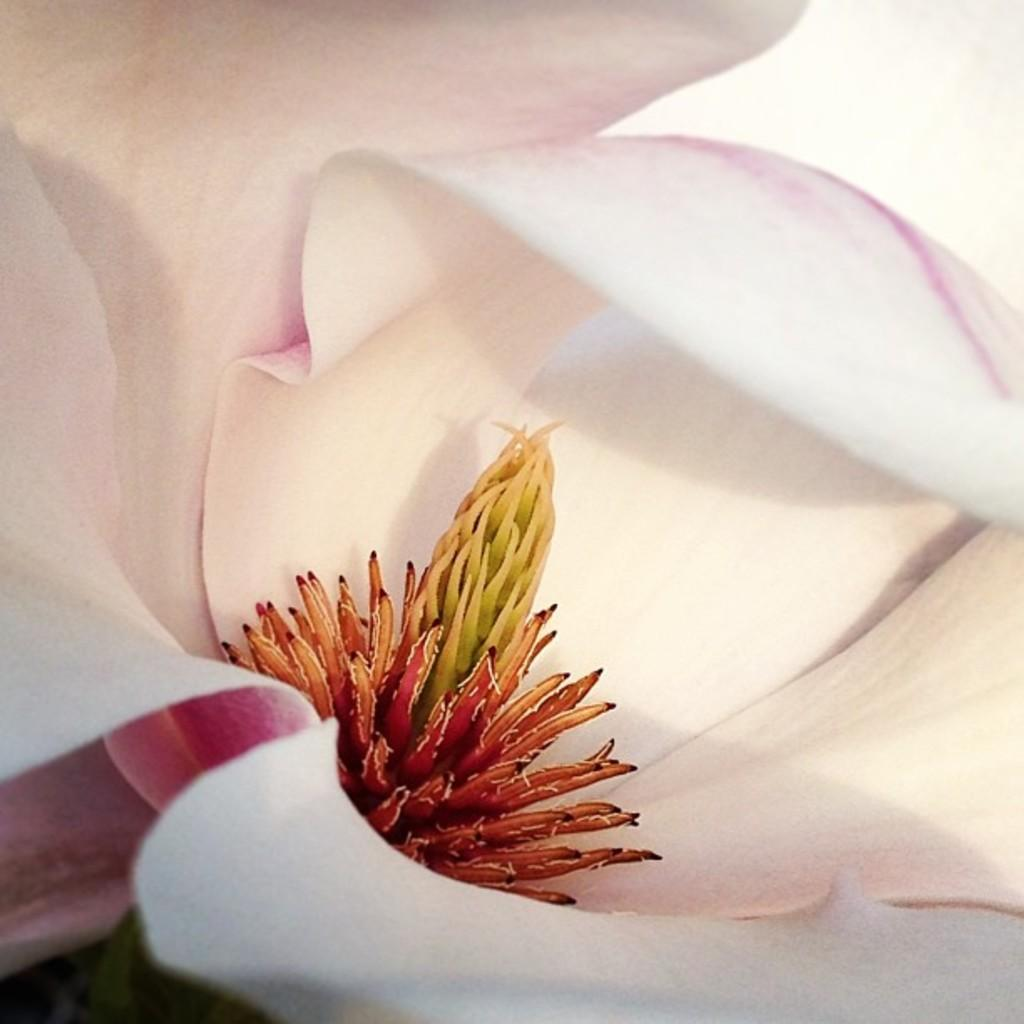What type of image is being shown? The image is a zoom in picture. What can be seen in the zoomed-in image? The flower in the image is white in color. What type of minister is depicted in the image? There is no minister present in the image; it features a white flower. Can you describe the waves in the image? There are no waves present in the image; it features a white flower. 